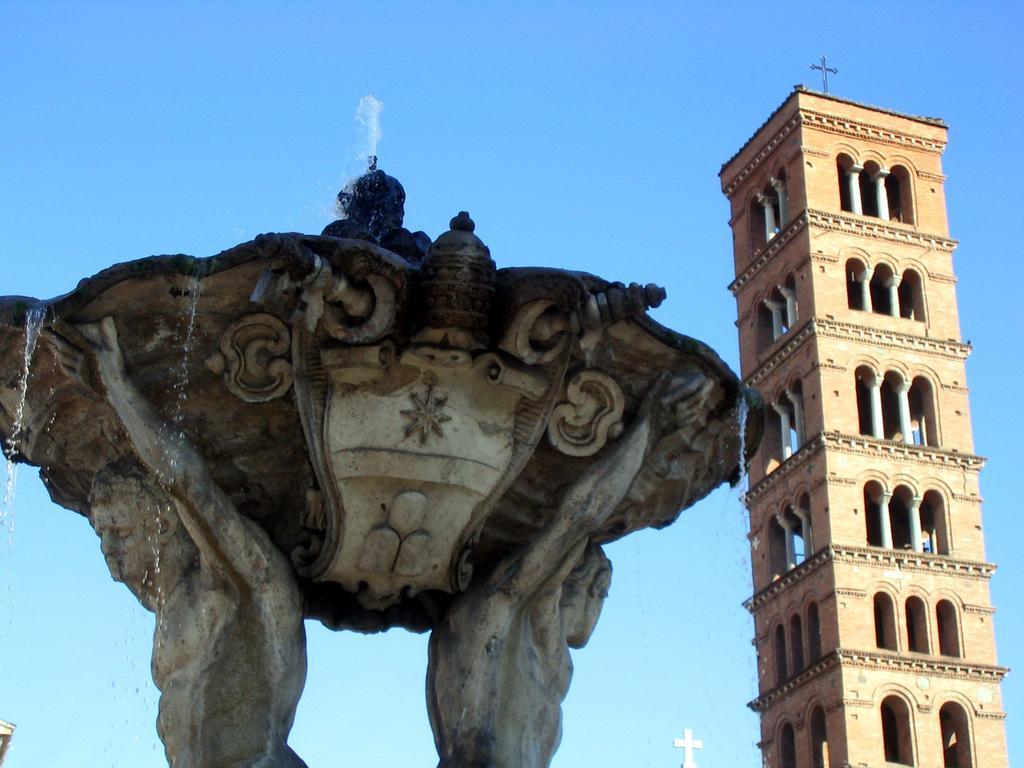How would you summarize this image in a sentence or two? In this image I can see a statue, buildings, fountain and the sky. This image is taken may be during a day. 